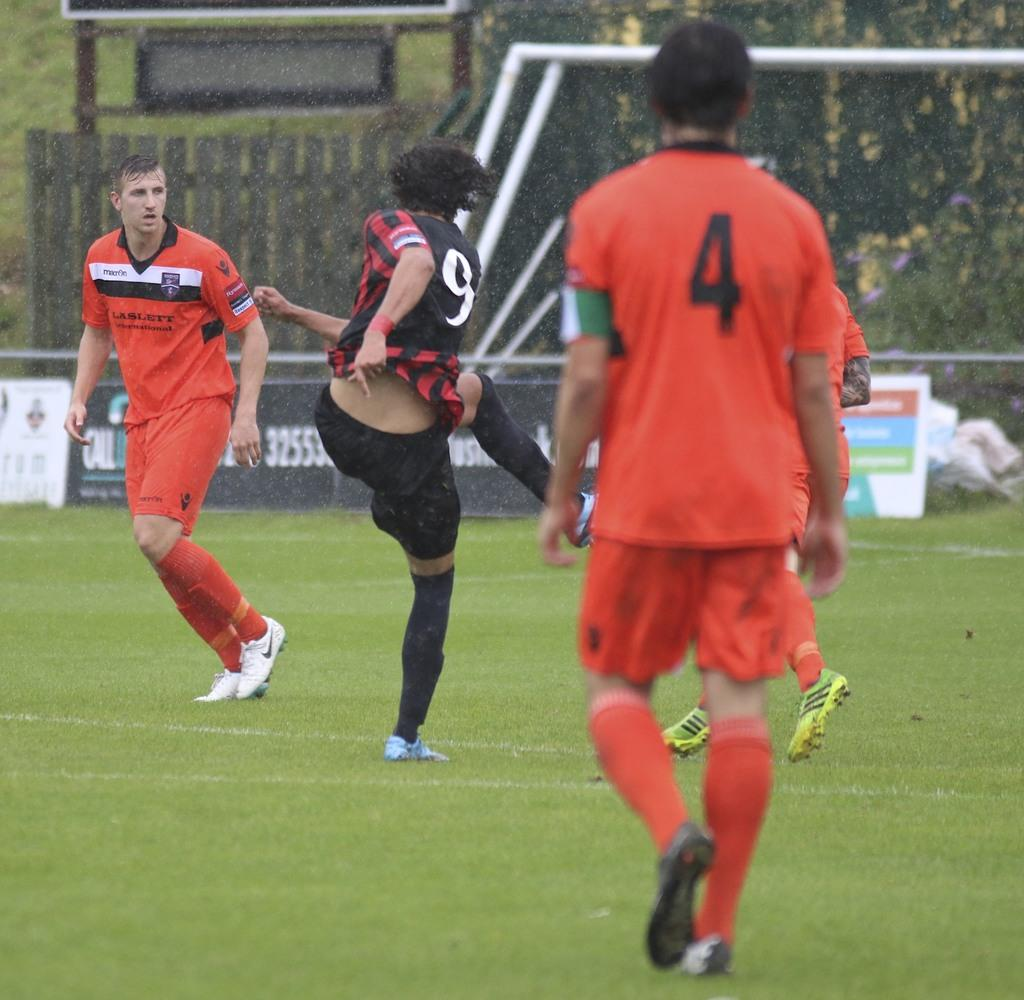What activity are the people in the image engaged in? The people in the image are playing football. What is the main feature of a football game? There is a goal post in the image, which is a key feature of a football game. What is written or displayed on the board in the image? There is a board with text in the image, but the specific content is not mentioned in the facts. What type of barrier is present in the image? There is fencing in the image. What type of natural scenery is visible in the image? There are trees visible in the image. What type of blade is being used by the family in the image? There is no mention of a family or a blade in the image; the facts only mention people playing football. 